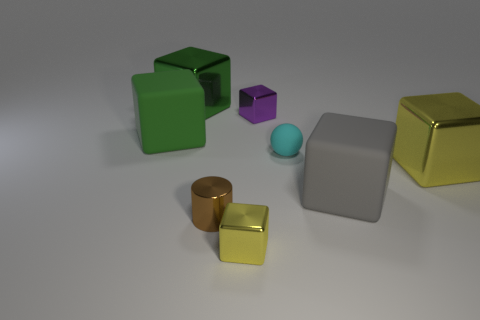What is the color of the shiny cube that is in front of the yellow thing on the right side of the tiny shiny cube behind the tiny yellow block?
Offer a very short reply. Yellow. Is the brown cylinder the same size as the green shiny object?
Your answer should be compact. No. What number of green rubber blocks have the same size as the purple metallic block?
Ensure brevity in your answer.  0. Do the block that is in front of the small shiny cylinder and the yellow block that is to the right of the small sphere have the same material?
Your answer should be compact. Yes. Is there any other thing that is the same shape as the cyan rubber object?
Your answer should be very brief. No. The small matte object is what color?
Your response must be concise. Cyan. How many other purple things have the same shape as the purple thing?
Provide a short and direct response. 0. There is a sphere that is the same size as the metal cylinder; what is its color?
Your answer should be compact. Cyan. Is there a small gray metal ball?
Make the answer very short. No. There is a tiny object that is behind the green matte object; what shape is it?
Make the answer very short. Cube. 